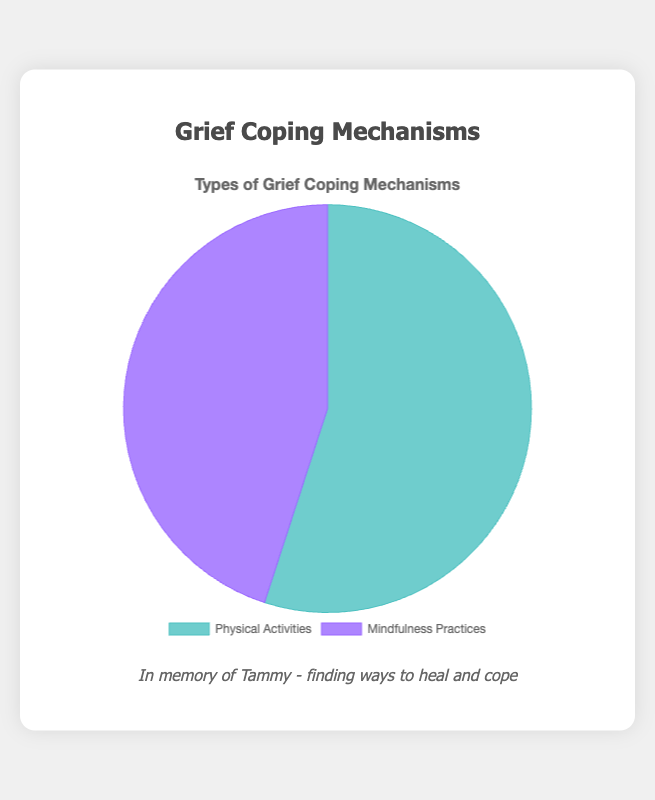What percentage of the chart is dedicated to Physical Activities? The chart shows that Physical Activities account for 55 out of the total 100 (55 + 45) units, thus 55%
Answer: 55% What part of the chart represents Mindfulness Practices? Mindfulness Practices account for 45 out of the total 100 (55 + 45) units, thus 45%
Answer: 45% Comparatively, which coping mechanism occupies a larger portion of the chart? By looking at the chart, Physical Activities represent a larger portion (55%) compared to Mindfulness Practices (45%)
Answer: Physical Activities How much larger is the Physical Activities section than the Mindfulness Practices section? (Percentage Difference) The difference between Physical Activities and Mindfulness Practices is 55% - 45% = 10%
Answer: 10% Which color represents the Mindfulness Practices section on the chart and how can you tell? Mindfulness Practices is represented by the purple-like color because it occupies 45% of the pie chart, which corresponds to that section
Answer: Purple If another coping mechanism were included and the chart needed to be rebalanced, what would the current percentage representation sum up to before adding the new mechanism? The current percentage representation sums up to 55% (Physical Activities) + 45% (Mindfulness Practices) = 100%
Answer: 100% How does the title of the chart help in understanding the data represented? The title "Types of Grief Coping Mechanisms" clarifies that the chart breaks down different methods people use to cope with grief into Physical Activities and Mindfulness Practices
Answer: It clarifies the data context What is the visual significance of the color differences in the chart? The color differences (aqua for Physical Activities and purple for Mindfulness Practices) visually distinguish between the two coping mechanisms, making it easier to identify them
Answer: Distinguishes mechanisms How does the position of the legend affect the readability of the chart? The legend being positioned at the bottom allows readers to easily match the colors with their respective labels without cluttering the main chart area
Answer: Enhances readability 